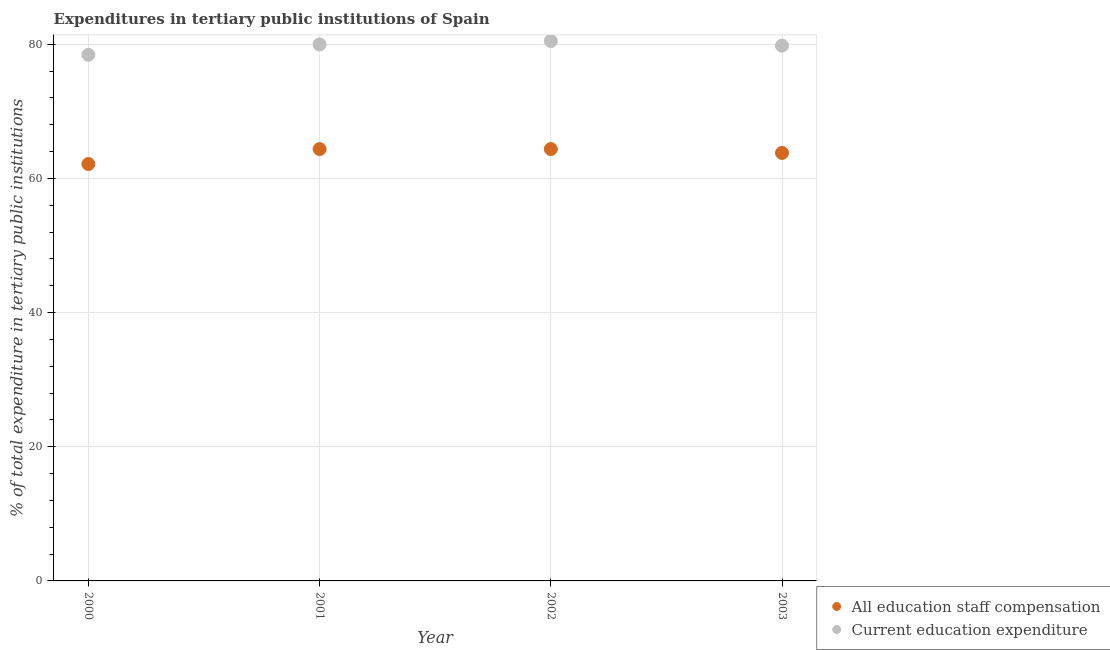How many different coloured dotlines are there?
Keep it short and to the point. 2. What is the expenditure in education in 2000?
Offer a very short reply. 78.44. Across all years, what is the maximum expenditure in staff compensation?
Give a very brief answer. 64.38. Across all years, what is the minimum expenditure in education?
Keep it short and to the point. 78.44. In which year was the expenditure in staff compensation maximum?
Offer a very short reply. 2002. What is the total expenditure in staff compensation in the graph?
Provide a short and direct response. 254.72. What is the difference between the expenditure in education in 2002 and that in 2003?
Offer a very short reply. 0.69. What is the difference between the expenditure in education in 2003 and the expenditure in staff compensation in 2001?
Your response must be concise. 15.42. What is the average expenditure in staff compensation per year?
Make the answer very short. 63.68. In the year 2003, what is the difference between the expenditure in staff compensation and expenditure in education?
Offer a terse response. -15.99. What is the ratio of the expenditure in staff compensation in 2000 to that in 2003?
Ensure brevity in your answer.  0.97. Is the difference between the expenditure in staff compensation in 2001 and 2002 greater than the difference between the expenditure in education in 2001 and 2002?
Keep it short and to the point. Yes. What is the difference between the highest and the second highest expenditure in education?
Keep it short and to the point. 0.51. What is the difference between the highest and the lowest expenditure in education?
Provide a succinct answer. 2.05. Does the expenditure in staff compensation monotonically increase over the years?
Offer a very short reply. No. Is the expenditure in staff compensation strictly less than the expenditure in education over the years?
Provide a succinct answer. Yes. How many years are there in the graph?
Offer a very short reply. 4. Does the graph contain any zero values?
Provide a short and direct response. No. Where does the legend appear in the graph?
Give a very brief answer. Bottom right. What is the title of the graph?
Offer a very short reply. Expenditures in tertiary public institutions of Spain. Does "US$" appear as one of the legend labels in the graph?
Offer a terse response. No. What is the label or title of the X-axis?
Provide a short and direct response. Year. What is the label or title of the Y-axis?
Your answer should be very brief. % of total expenditure in tertiary public institutions. What is the % of total expenditure in tertiary public institutions in All education staff compensation in 2000?
Give a very brief answer. 62.15. What is the % of total expenditure in tertiary public institutions in Current education expenditure in 2000?
Your answer should be very brief. 78.44. What is the % of total expenditure in tertiary public institutions of All education staff compensation in 2001?
Offer a very short reply. 64.38. What is the % of total expenditure in tertiary public institutions in Current education expenditure in 2001?
Your answer should be compact. 79.98. What is the % of total expenditure in tertiary public institutions in All education staff compensation in 2002?
Ensure brevity in your answer.  64.38. What is the % of total expenditure in tertiary public institutions in Current education expenditure in 2002?
Your answer should be very brief. 80.49. What is the % of total expenditure in tertiary public institutions of All education staff compensation in 2003?
Ensure brevity in your answer.  63.8. What is the % of total expenditure in tertiary public institutions in Current education expenditure in 2003?
Offer a terse response. 79.8. Across all years, what is the maximum % of total expenditure in tertiary public institutions in All education staff compensation?
Offer a terse response. 64.38. Across all years, what is the maximum % of total expenditure in tertiary public institutions of Current education expenditure?
Your response must be concise. 80.49. Across all years, what is the minimum % of total expenditure in tertiary public institutions of All education staff compensation?
Provide a short and direct response. 62.15. Across all years, what is the minimum % of total expenditure in tertiary public institutions of Current education expenditure?
Make the answer very short. 78.44. What is the total % of total expenditure in tertiary public institutions in All education staff compensation in the graph?
Provide a short and direct response. 254.72. What is the total % of total expenditure in tertiary public institutions of Current education expenditure in the graph?
Provide a short and direct response. 318.7. What is the difference between the % of total expenditure in tertiary public institutions in All education staff compensation in 2000 and that in 2001?
Ensure brevity in your answer.  -2.23. What is the difference between the % of total expenditure in tertiary public institutions in Current education expenditure in 2000 and that in 2001?
Provide a succinct answer. -1.54. What is the difference between the % of total expenditure in tertiary public institutions of All education staff compensation in 2000 and that in 2002?
Your answer should be very brief. -2.23. What is the difference between the % of total expenditure in tertiary public institutions of Current education expenditure in 2000 and that in 2002?
Ensure brevity in your answer.  -2.05. What is the difference between the % of total expenditure in tertiary public institutions of All education staff compensation in 2000 and that in 2003?
Give a very brief answer. -1.65. What is the difference between the % of total expenditure in tertiary public institutions in Current education expenditure in 2000 and that in 2003?
Give a very brief answer. -1.36. What is the difference between the % of total expenditure in tertiary public institutions of All education staff compensation in 2001 and that in 2002?
Provide a short and direct response. -0. What is the difference between the % of total expenditure in tertiary public institutions of Current education expenditure in 2001 and that in 2002?
Offer a very short reply. -0.51. What is the difference between the % of total expenditure in tertiary public institutions in All education staff compensation in 2001 and that in 2003?
Ensure brevity in your answer.  0.58. What is the difference between the % of total expenditure in tertiary public institutions of Current education expenditure in 2001 and that in 2003?
Your answer should be very brief. 0.19. What is the difference between the % of total expenditure in tertiary public institutions of All education staff compensation in 2002 and that in 2003?
Offer a terse response. 0.58. What is the difference between the % of total expenditure in tertiary public institutions in Current education expenditure in 2002 and that in 2003?
Make the answer very short. 0.69. What is the difference between the % of total expenditure in tertiary public institutions of All education staff compensation in 2000 and the % of total expenditure in tertiary public institutions of Current education expenditure in 2001?
Make the answer very short. -17.83. What is the difference between the % of total expenditure in tertiary public institutions of All education staff compensation in 2000 and the % of total expenditure in tertiary public institutions of Current education expenditure in 2002?
Provide a short and direct response. -18.34. What is the difference between the % of total expenditure in tertiary public institutions of All education staff compensation in 2000 and the % of total expenditure in tertiary public institutions of Current education expenditure in 2003?
Give a very brief answer. -17.65. What is the difference between the % of total expenditure in tertiary public institutions of All education staff compensation in 2001 and the % of total expenditure in tertiary public institutions of Current education expenditure in 2002?
Your response must be concise. -16.11. What is the difference between the % of total expenditure in tertiary public institutions in All education staff compensation in 2001 and the % of total expenditure in tertiary public institutions in Current education expenditure in 2003?
Your answer should be very brief. -15.41. What is the difference between the % of total expenditure in tertiary public institutions in All education staff compensation in 2002 and the % of total expenditure in tertiary public institutions in Current education expenditure in 2003?
Provide a short and direct response. -15.41. What is the average % of total expenditure in tertiary public institutions of All education staff compensation per year?
Provide a succinct answer. 63.68. What is the average % of total expenditure in tertiary public institutions of Current education expenditure per year?
Give a very brief answer. 79.68. In the year 2000, what is the difference between the % of total expenditure in tertiary public institutions in All education staff compensation and % of total expenditure in tertiary public institutions in Current education expenditure?
Provide a short and direct response. -16.29. In the year 2001, what is the difference between the % of total expenditure in tertiary public institutions of All education staff compensation and % of total expenditure in tertiary public institutions of Current education expenditure?
Your answer should be very brief. -15.6. In the year 2002, what is the difference between the % of total expenditure in tertiary public institutions of All education staff compensation and % of total expenditure in tertiary public institutions of Current education expenditure?
Keep it short and to the point. -16.1. In the year 2003, what is the difference between the % of total expenditure in tertiary public institutions of All education staff compensation and % of total expenditure in tertiary public institutions of Current education expenditure?
Offer a very short reply. -15.99. What is the ratio of the % of total expenditure in tertiary public institutions in All education staff compensation in 2000 to that in 2001?
Provide a succinct answer. 0.97. What is the ratio of the % of total expenditure in tertiary public institutions in Current education expenditure in 2000 to that in 2001?
Your answer should be compact. 0.98. What is the ratio of the % of total expenditure in tertiary public institutions in All education staff compensation in 2000 to that in 2002?
Provide a succinct answer. 0.97. What is the ratio of the % of total expenditure in tertiary public institutions in Current education expenditure in 2000 to that in 2002?
Ensure brevity in your answer.  0.97. What is the ratio of the % of total expenditure in tertiary public institutions of All education staff compensation in 2000 to that in 2003?
Keep it short and to the point. 0.97. What is the ratio of the % of total expenditure in tertiary public institutions of Current education expenditure in 2000 to that in 2003?
Give a very brief answer. 0.98. What is the ratio of the % of total expenditure in tertiary public institutions of Current education expenditure in 2001 to that in 2002?
Provide a succinct answer. 0.99. What is the ratio of the % of total expenditure in tertiary public institutions of All education staff compensation in 2001 to that in 2003?
Ensure brevity in your answer.  1.01. What is the ratio of the % of total expenditure in tertiary public institutions of Current education expenditure in 2001 to that in 2003?
Keep it short and to the point. 1. What is the ratio of the % of total expenditure in tertiary public institutions in All education staff compensation in 2002 to that in 2003?
Give a very brief answer. 1.01. What is the ratio of the % of total expenditure in tertiary public institutions of Current education expenditure in 2002 to that in 2003?
Make the answer very short. 1.01. What is the difference between the highest and the second highest % of total expenditure in tertiary public institutions of All education staff compensation?
Your answer should be very brief. 0. What is the difference between the highest and the second highest % of total expenditure in tertiary public institutions of Current education expenditure?
Your answer should be compact. 0.51. What is the difference between the highest and the lowest % of total expenditure in tertiary public institutions of All education staff compensation?
Give a very brief answer. 2.23. What is the difference between the highest and the lowest % of total expenditure in tertiary public institutions of Current education expenditure?
Make the answer very short. 2.05. 